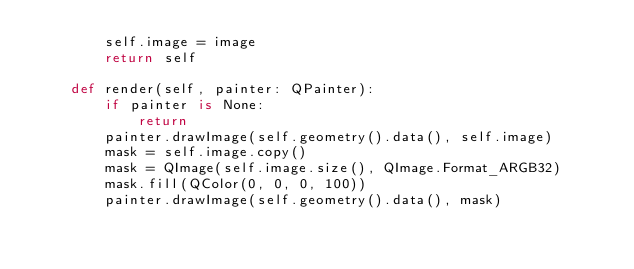Convert code to text. <code><loc_0><loc_0><loc_500><loc_500><_Python_>        self.image = image
        return self

    def render(self, painter: QPainter):
        if painter is None:
            return
        painter.drawImage(self.geometry().data(), self.image)
        mask = self.image.copy()
        mask = QImage(self.image.size(), QImage.Format_ARGB32)
        mask.fill(QColor(0, 0, 0, 100))
        painter.drawImage(self.geometry().data(), mask)
</code> 